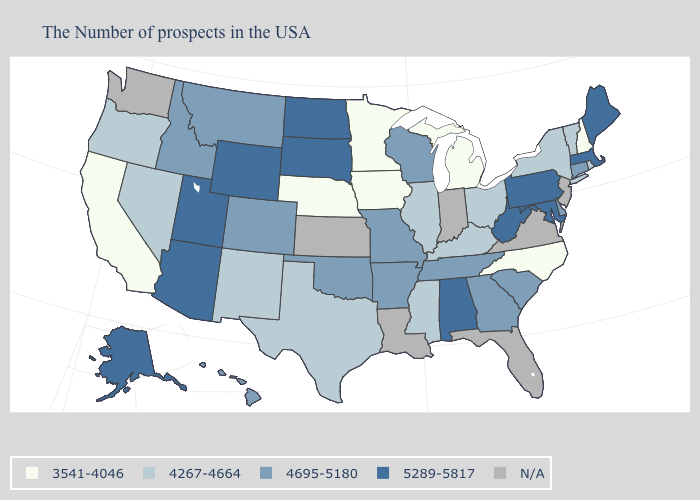Name the states that have a value in the range 4267-4664?
Quick response, please. Rhode Island, Vermont, New York, Ohio, Kentucky, Illinois, Mississippi, Texas, New Mexico, Nevada, Oregon. Does the first symbol in the legend represent the smallest category?
Be succinct. Yes. Among the states that border Pennsylvania , does West Virginia have the lowest value?
Give a very brief answer. No. Among the states that border Massachusetts , does New Hampshire have the lowest value?
Answer briefly. Yes. Which states have the highest value in the USA?
Keep it brief. Maine, Massachusetts, Maryland, Pennsylvania, West Virginia, Alabama, South Dakota, North Dakota, Wyoming, Utah, Arizona, Alaska. What is the value of Montana?
Concise answer only. 4695-5180. What is the value of Kansas?
Short answer required. N/A. Name the states that have a value in the range 4695-5180?
Quick response, please. Connecticut, Delaware, South Carolina, Georgia, Tennessee, Wisconsin, Missouri, Arkansas, Oklahoma, Colorado, Montana, Idaho, Hawaii. Does the first symbol in the legend represent the smallest category?
Short answer required. Yes. Does the map have missing data?
Write a very short answer. Yes. Among the states that border Kentucky , does Ohio have the lowest value?
Short answer required. Yes. What is the value of Michigan?
Answer briefly. 3541-4046. What is the value of South Carolina?
Keep it brief. 4695-5180. Name the states that have a value in the range N/A?
Answer briefly. New Jersey, Virginia, Florida, Indiana, Louisiana, Kansas, Washington. Name the states that have a value in the range 4267-4664?
Concise answer only. Rhode Island, Vermont, New York, Ohio, Kentucky, Illinois, Mississippi, Texas, New Mexico, Nevada, Oregon. 